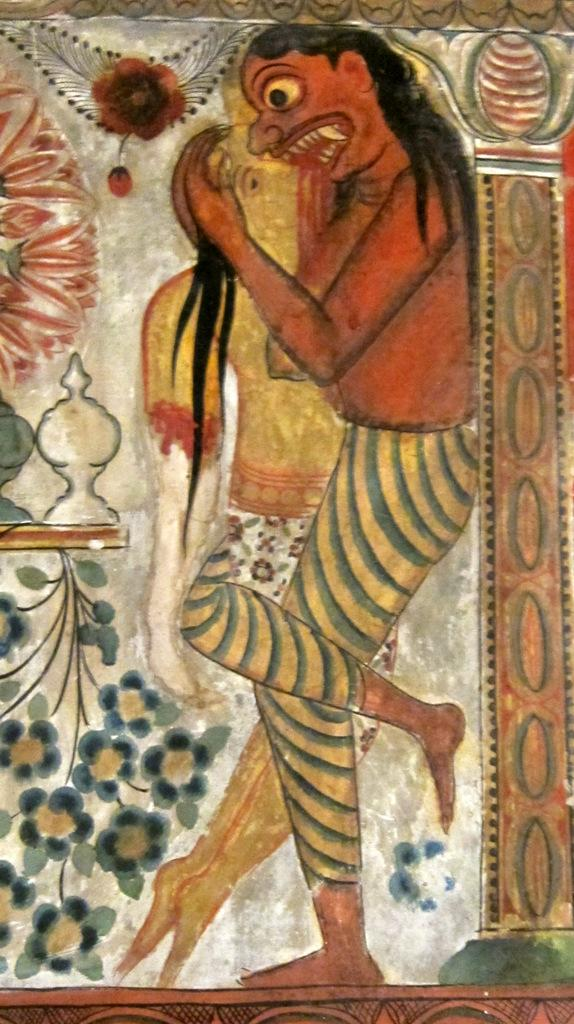What is the main subject of the image? The main subject of the image is a depiction of persons. Can you describe any additional elements in the image? Yes, there are some designs in the image. What type of pin is being used by the persons in the image? There is no pin visible in the image; it only depicts persons and designs. How many yaks are present in the image? There are no yaks present in the image. 